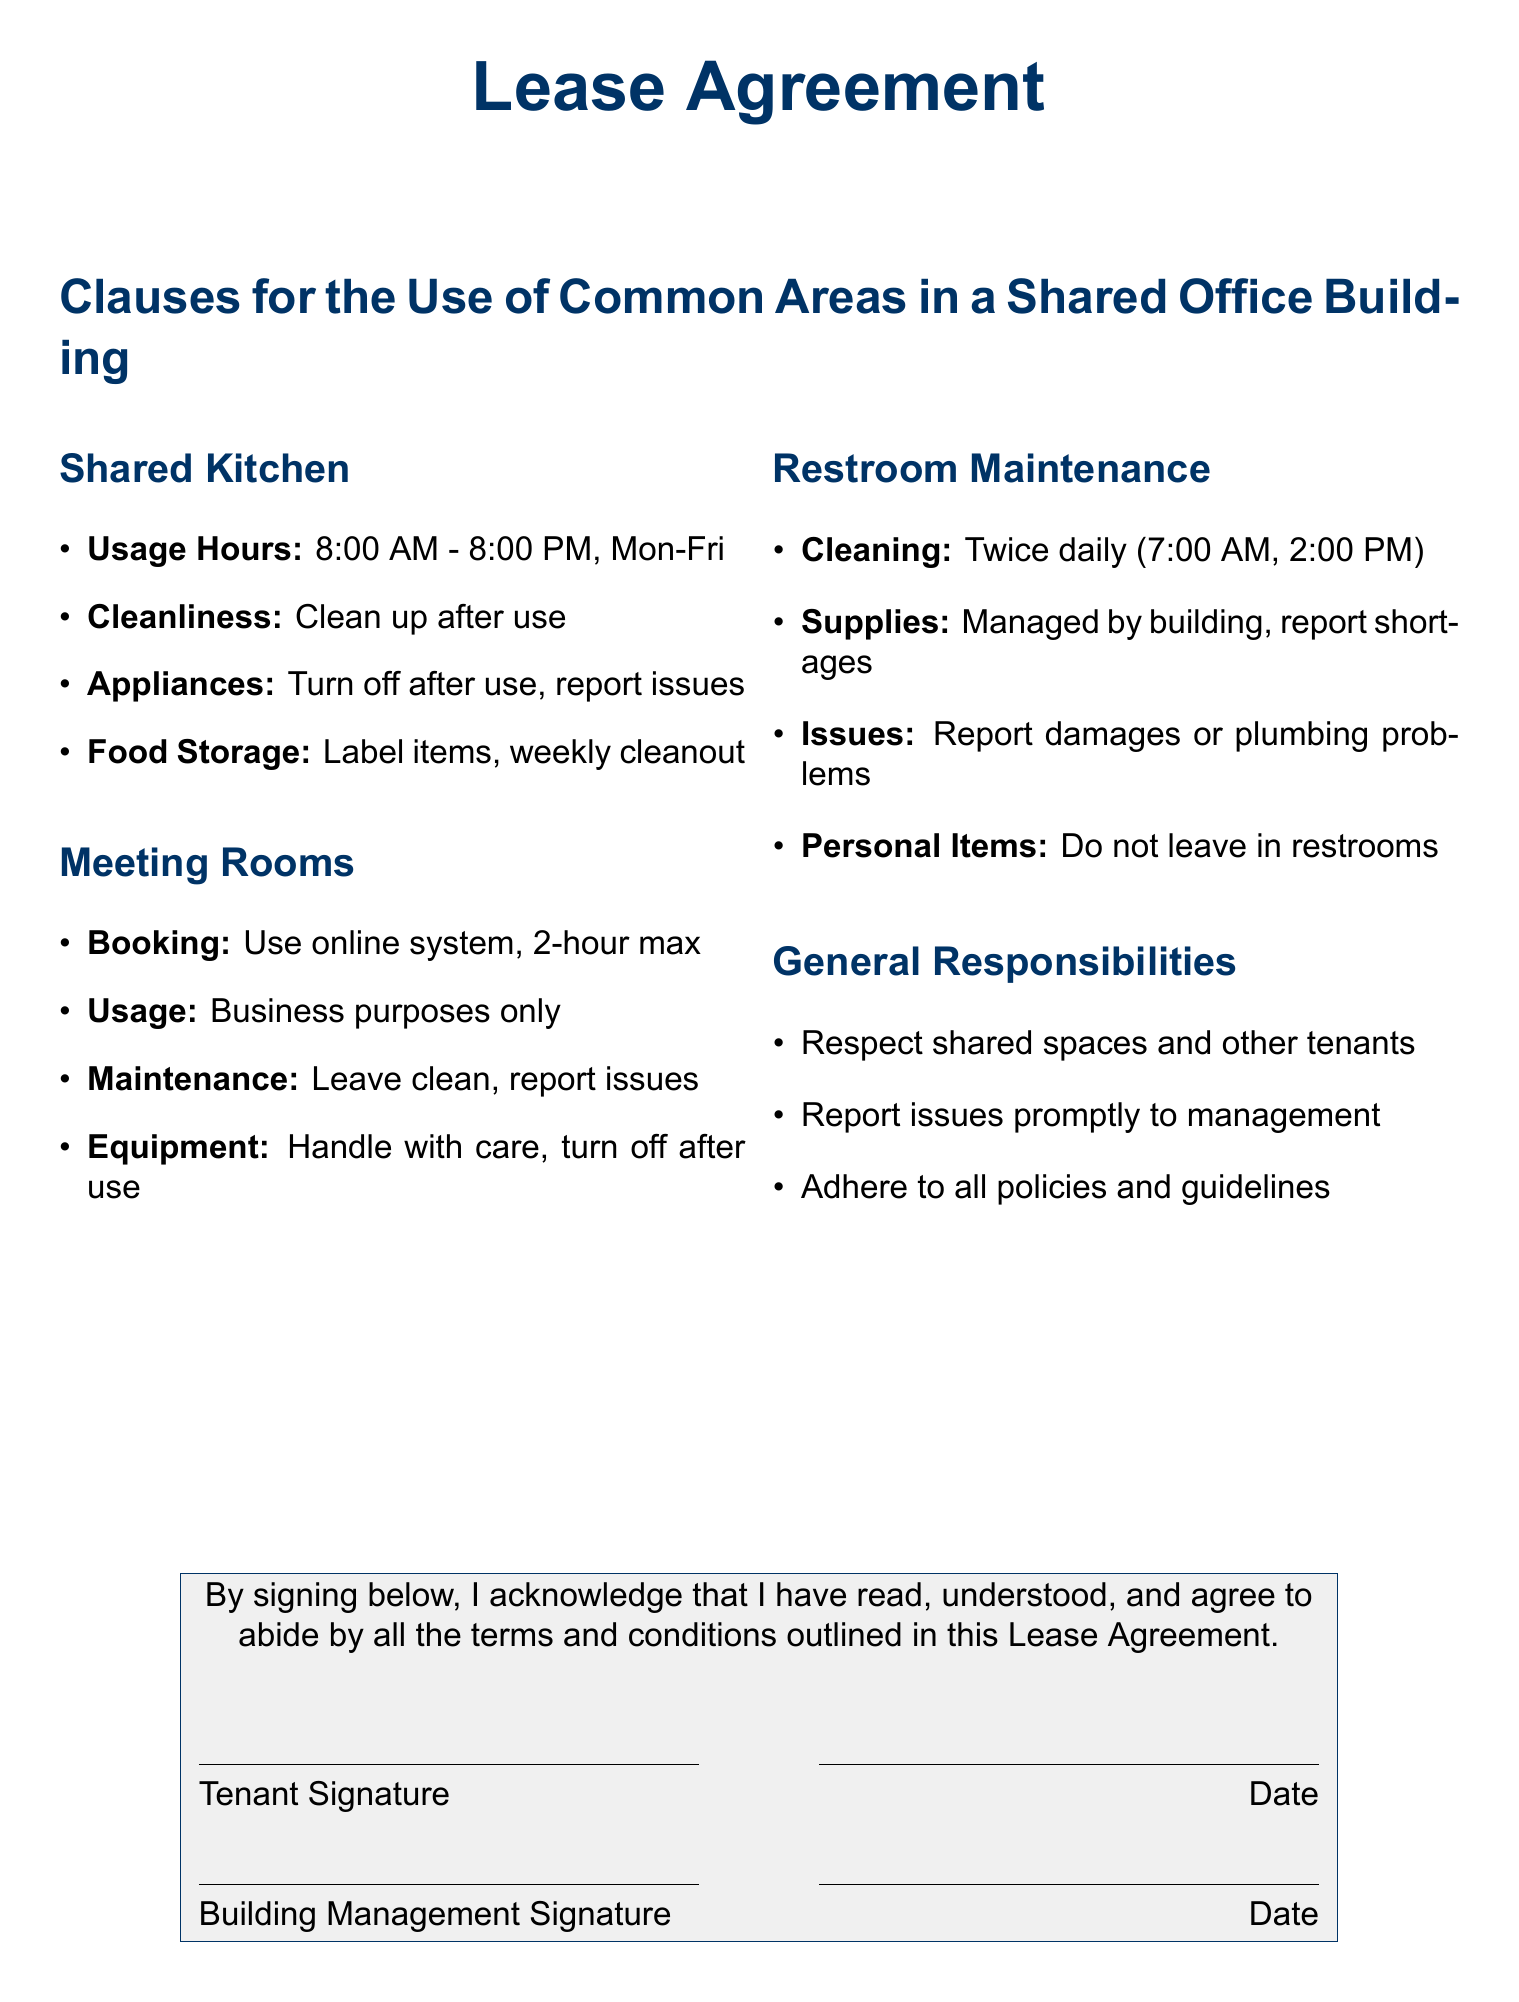what are the usage hours for the shared kitchen? The usage hours for the shared kitchen are specified in the document as 8:00 AM to 8:00 PM, Monday to Friday.
Answer: 8:00 AM - 8:00 PM, Mon-Fri how often is the restroom cleaned? The document states that the restroom is cleaned twice daily, indicating the frequency of maintenance.
Answer: Twice daily what is the maximum booking time for meeting rooms? The document specifies a maximum booking time for meeting rooms and outlines the restrictions on their use.
Answer: 2-hour max what must tenants do after using appliances in the kitchen? The document outlines responsibilities for kitchen use, including actions to take after using appliances.
Answer: Turn off after use what should be reported if there are issues in common areas? The document indicates responsibilities for reporting problems in shared spaces, emphasizing the need for communication with management.
Answer: Report issues how should food items be managed in the shared kitchen? The document includes specific guidelines for food item storage and management in the shared kitchen area.
Answer: Label items, weekly cleanout what is forbidden in restrooms according to the document? The document mentions specific items that are not allowed to be left in restrooms, which reflects tenant responsibilities.
Answer: Do not leave in restrooms what is the purpose of using meeting rooms? The document restricts the usage of meeting rooms to a specific purpose outlined within the clauses.
Answer: Business purposes only who must sign the lease agreement? The document specifies who must sign and acknowledge the lease agreement, indicating involved parties.
Answer: Tenant and Building Management 